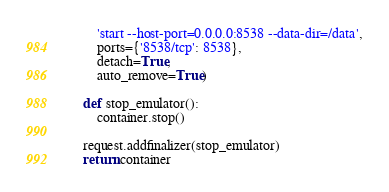Convert code to text. <code><loc_0><loc_0><loc_500><loc_500><_Python_>        'start --host-port=0.0.0.0:8538 --data-dir=/data',
        ports={'8538/tcp': 8538},
        detach=True,
        auto_remove=True)

    def stop_emulator():
        container.stop()

    request.addfinalizer(stop_emulator)
    return container
</code> 